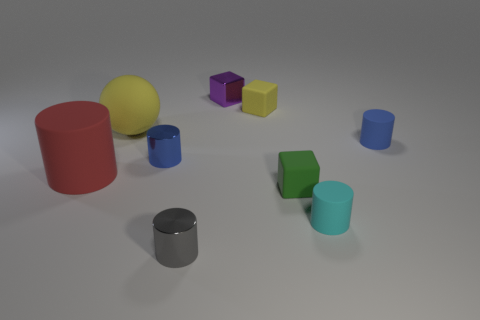Can you describe the composition of the shapes in the scene? Certainly! The scene is composed of a variety of simple geometric shapes, including spheres, cylinders, and cubes. These shapes are arranged in a somewhat scattered fashion across a flat surface, with a mix of sizes and colors that create a visually balanced yet informal array. 